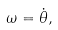<formula> <loc_0><loc_0><loc_500><loc_500>\omega = { \dot { \theta } } ,</formula> 